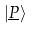Convert formula to latex. <formula><loc_0><loc_0><loc_500><loc_500>| \underline { P } \rangle</formula> 